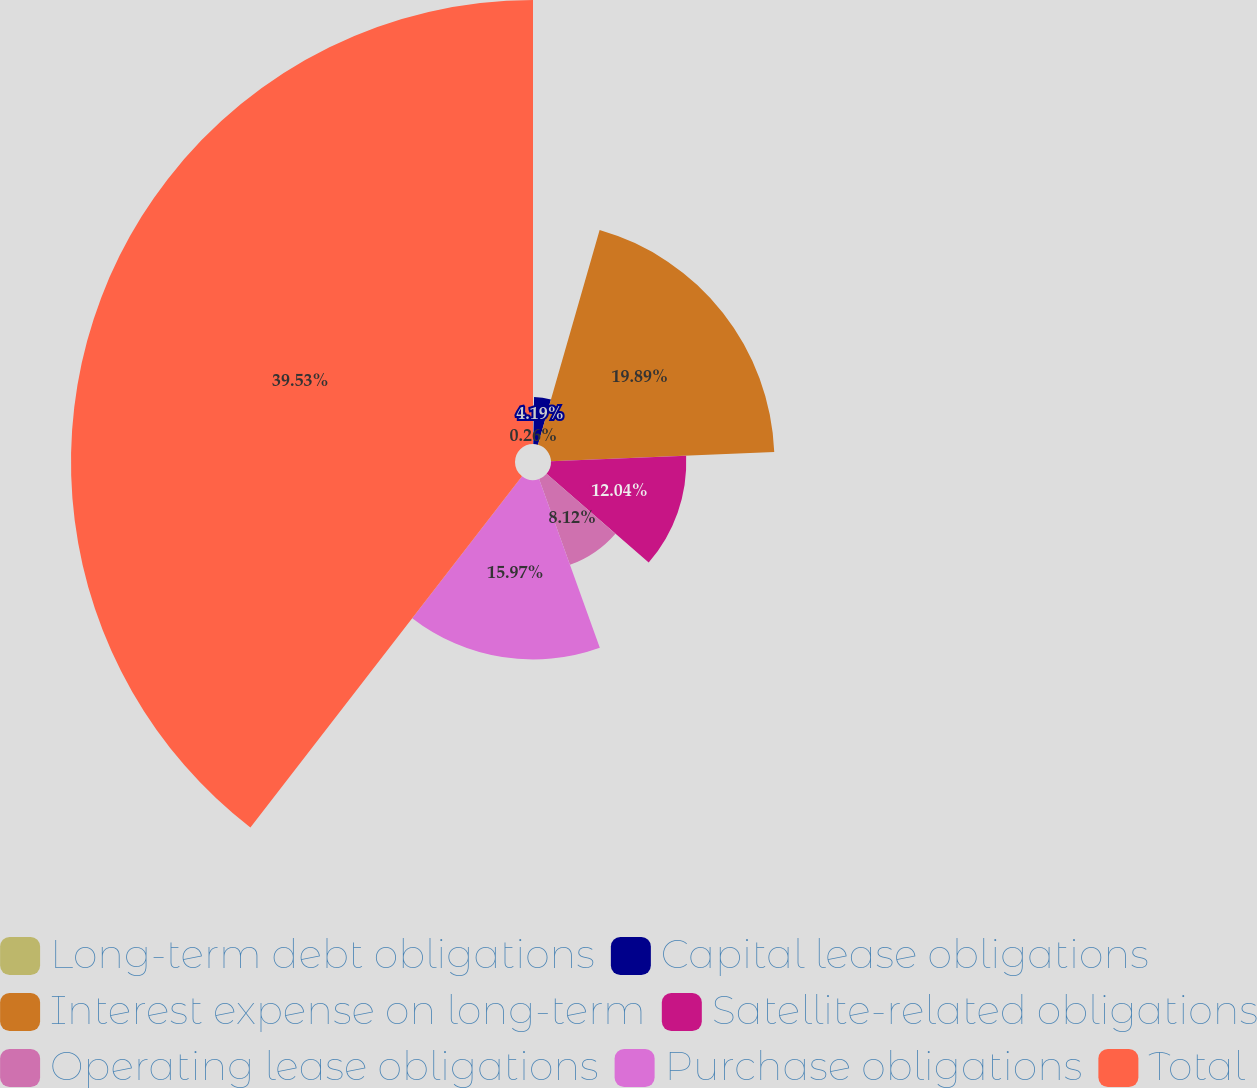Convert chart. <chart><loc_0><loc_0><loc_500><loc_500><pie_chart><fcel>Long-term debt obligations<fcel>Capital lease obligations<fcel>Interest expense on long-term<fcel>Satellite-related obligations<fcel>Operating lease obligations<fcel>Purchase obligations<fcel>Total<nl><fcel>0.26%<fcel>4.19%<fcel>19.89%<fcel>12.04%<fcel>8.12%<fcel>15.97%<fcel>39.52%<nl></chart> 